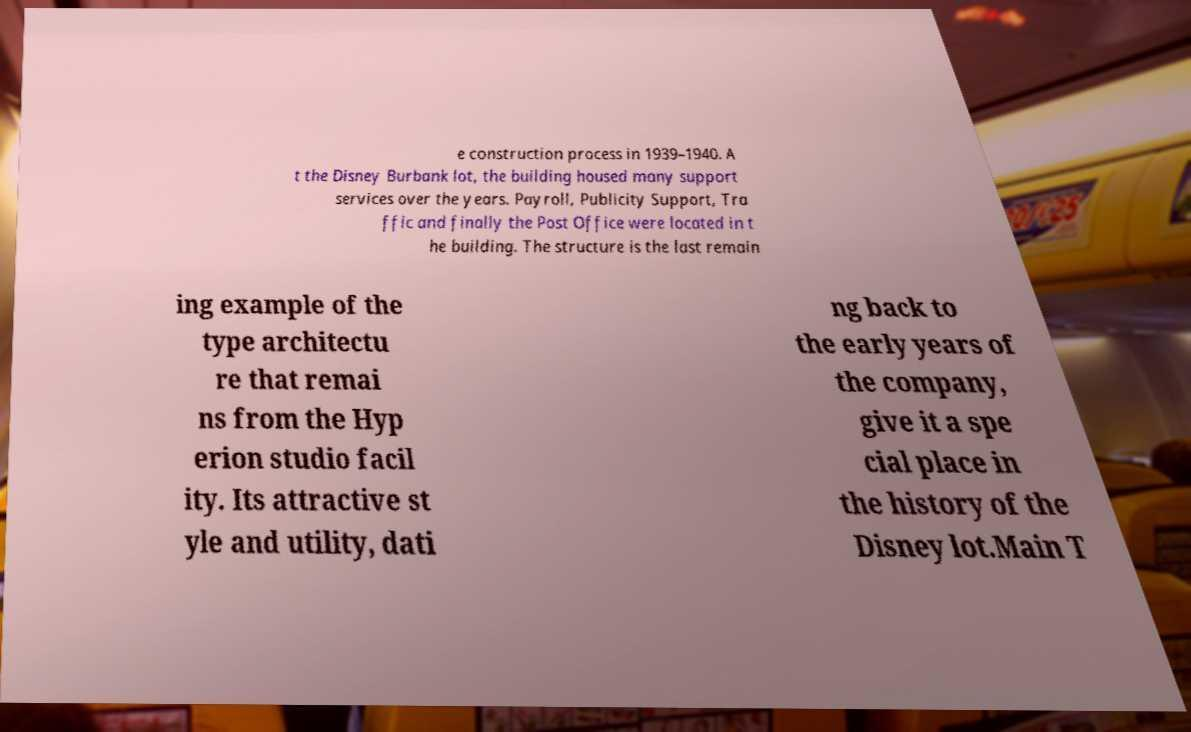Could you extract and type out the text from this image? e construction process in 1939–1940. A t the Disney Burbank lot, the building housed many support services over the years. Payroll, Publicity Support, Tra ffic and finally the Post Office were located in t he building. The structure is the last remain ing example of the type architectu re that remai ns from the Hyp erion studio facil ity. Its attractive st yle and utility, dati ng back to the early years of the company, give it a spe cial place in the history of the Disney lot.Main T 